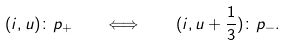<formula> <loc_0><loc_0><loc_500><loc_500>( i , u ) \colon p _ { + } \quad \Longleftrightarrow \quad ( i , u + \frac { 1 } { 3 } ) \colon p _ { - } .</formula> 